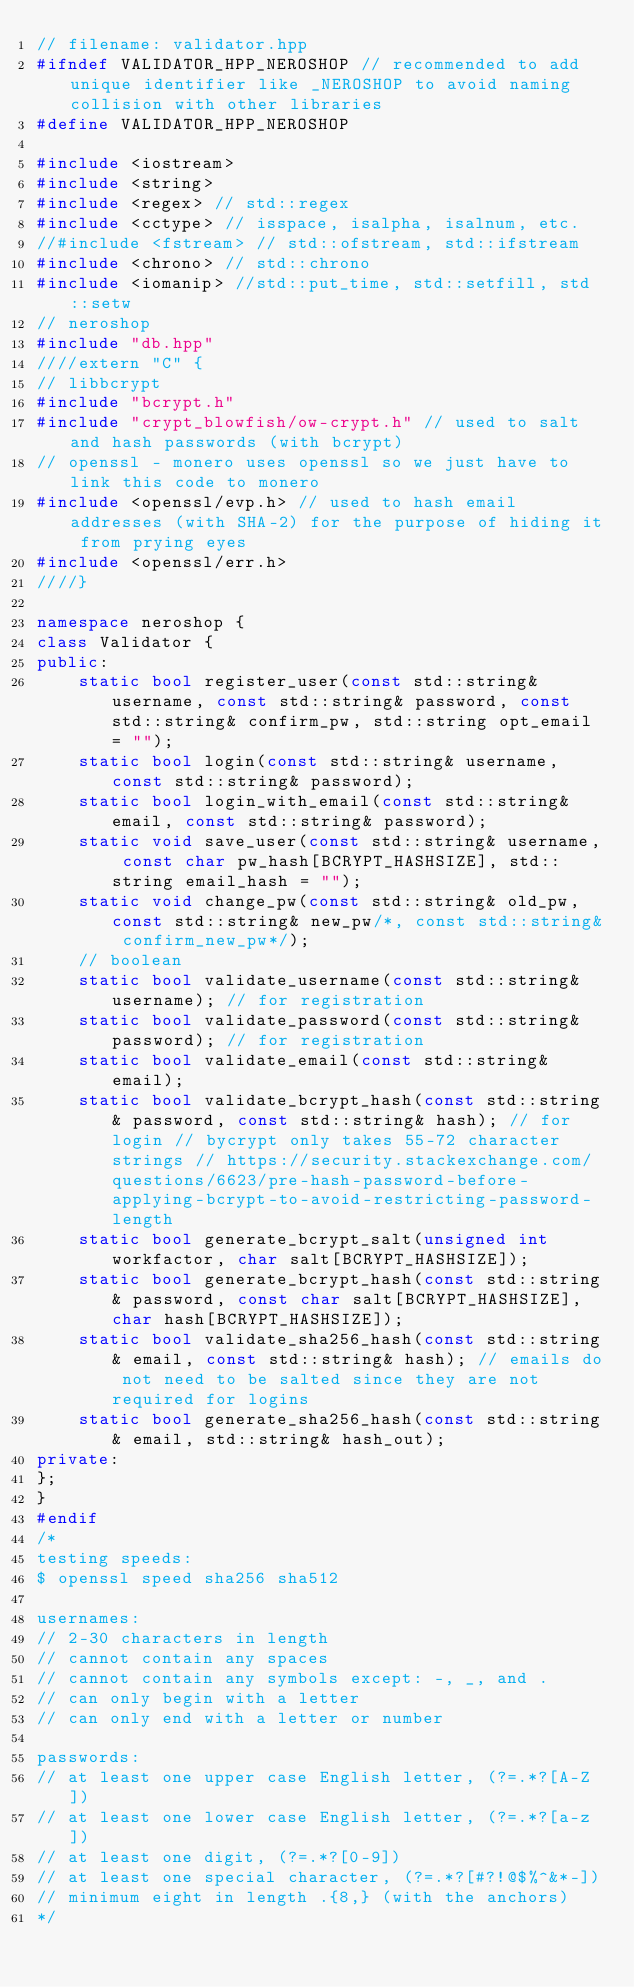Convert code to text. <code><loc_0><loc_0><loc_500><loc_500><_C++_>// filename: validator.hpp
#ifndef VALIDATOR_HPP_NEROSHOP // recommended to add unique identifier like _NEROSHOP to avoid naming collision with other libraries
#define VALIDATOR_HPP_NEROSHOP

#include <iostream>
#include <string>
#include <regex> // std::regex
#include <cctype> // isspace, isalpha, isalnum, etc.
//#include <fstream> // std::ofstream, std::ifstream
#include <chrono> // std::chrono
#include <iomanip> //std::put_time, std::setfill, std::setw
// neroshop
#include "db.hpp"
////extern "C" {
// libbcrypt
#include "bcrypt.h"
#include "crypt_blowfish/ow-crypt.h" // used to salt and hash passwords (with bcrypt)
// openssl - monero uses openssl so we just have to link this code to monero
#include <openssl/evp.h> // used to hash email addresses (with SHA-2) for the purpose of hiding it from prying eyes
#include <openssl/err.h>
////}

namespace neroshop {
class Validator {
public:
    static bool register_user(const std::string& username, const std::string& password, const std::string& confirm_pw, std::string opt_email = "");
    static bool login(const std::string& username, const std::string& password);
    static bool login_with_email(const std::string& email, const std::string& password);
    static void save_user(const std::string& username, const char pw_hash[BCRYPT_HASHSIZE], std::string email_hash = "");
    static void change_pw(const std::string& old_pw, const std::string& new_pw/*, const std::string& confirm_new_pw*/);
    // boolean
    static bool validate_username(const std::string& username); // for registration
    static bool validate_password(const std::string& password); // for registration
    static bool validate_email(const std::string& email);
    static bool validate_bcrypt_hash(const std::string& password, const std::string& hash); // for login // bycrypt only takes 55-72 character strings // https://security.stackexchange.com/questions/6623/pre-hash-password-before-applying-bcrypt-to-avoid-restricting-password-length
    static bool generate_bcrypt_salt(unsigned int workfactor, char salt[BCRYPT_HASHSIZE]);
    static bool generate_bcrypt_hash(const std::string& password, const char salt[BCRYPT_HASHSIZE], char hash[BCRYPT_HASHSIZE]);
    static bool validate_sha256_hash(const std::string& email, const std::string& hash); // emails do not need to be salted since they are not required for logins
    static bool generate_sha256_hash(const std::string& email, std::string& hash_out);
private:
};
}
#endif
/*
testing speeds:
$ openssl speed sha256 sha512

usernames:
// 2-30 characters in length
// cannot contain any spaces
// cannot contain any symbols except: -, _, and .
// can only begin with a letter
// can only end with a letter or number

passwords:
// at least one upper case English letter, (?=.*?[A-Z])
// at least one lower case English letter, (?=.*?[a-z])
// at least one digit, (?=.*?[0-9])
// at least one special character, (?=.*?[#?!@$%^&*-])
// minimum eight in length .{8,} (with the anchors) 
*/
</code> 